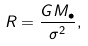Convert formula to latex. <formula><loc_0><loc_0><loc_500><loc_500>R = \frac { G M _ { \bullet } } { \sigma ^ { 2 } } ,</formula> 